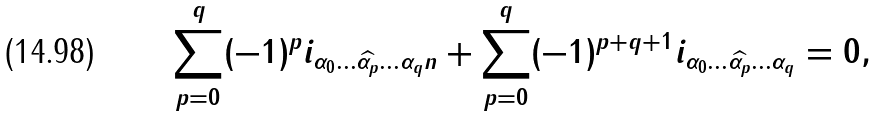<formula> <loc_0><loc_0><loc_500><loc_500>\sum _ { p = 0 } ^ { q } ( - 1 ) ^ { p } i _ { \alpha _ { 0 } \dots \widehat { \alpha _ { p } } \dots \alpha _ { q } n } + \sum _ { p = 0 } ^ { q } ( - 1 ) ^ { p + q + 1 } i _ { \alpha _ { 0 } \dots \widehat { \alpha _ { p } } \dots \alpha _ { q } } = 0 ,</formula> 